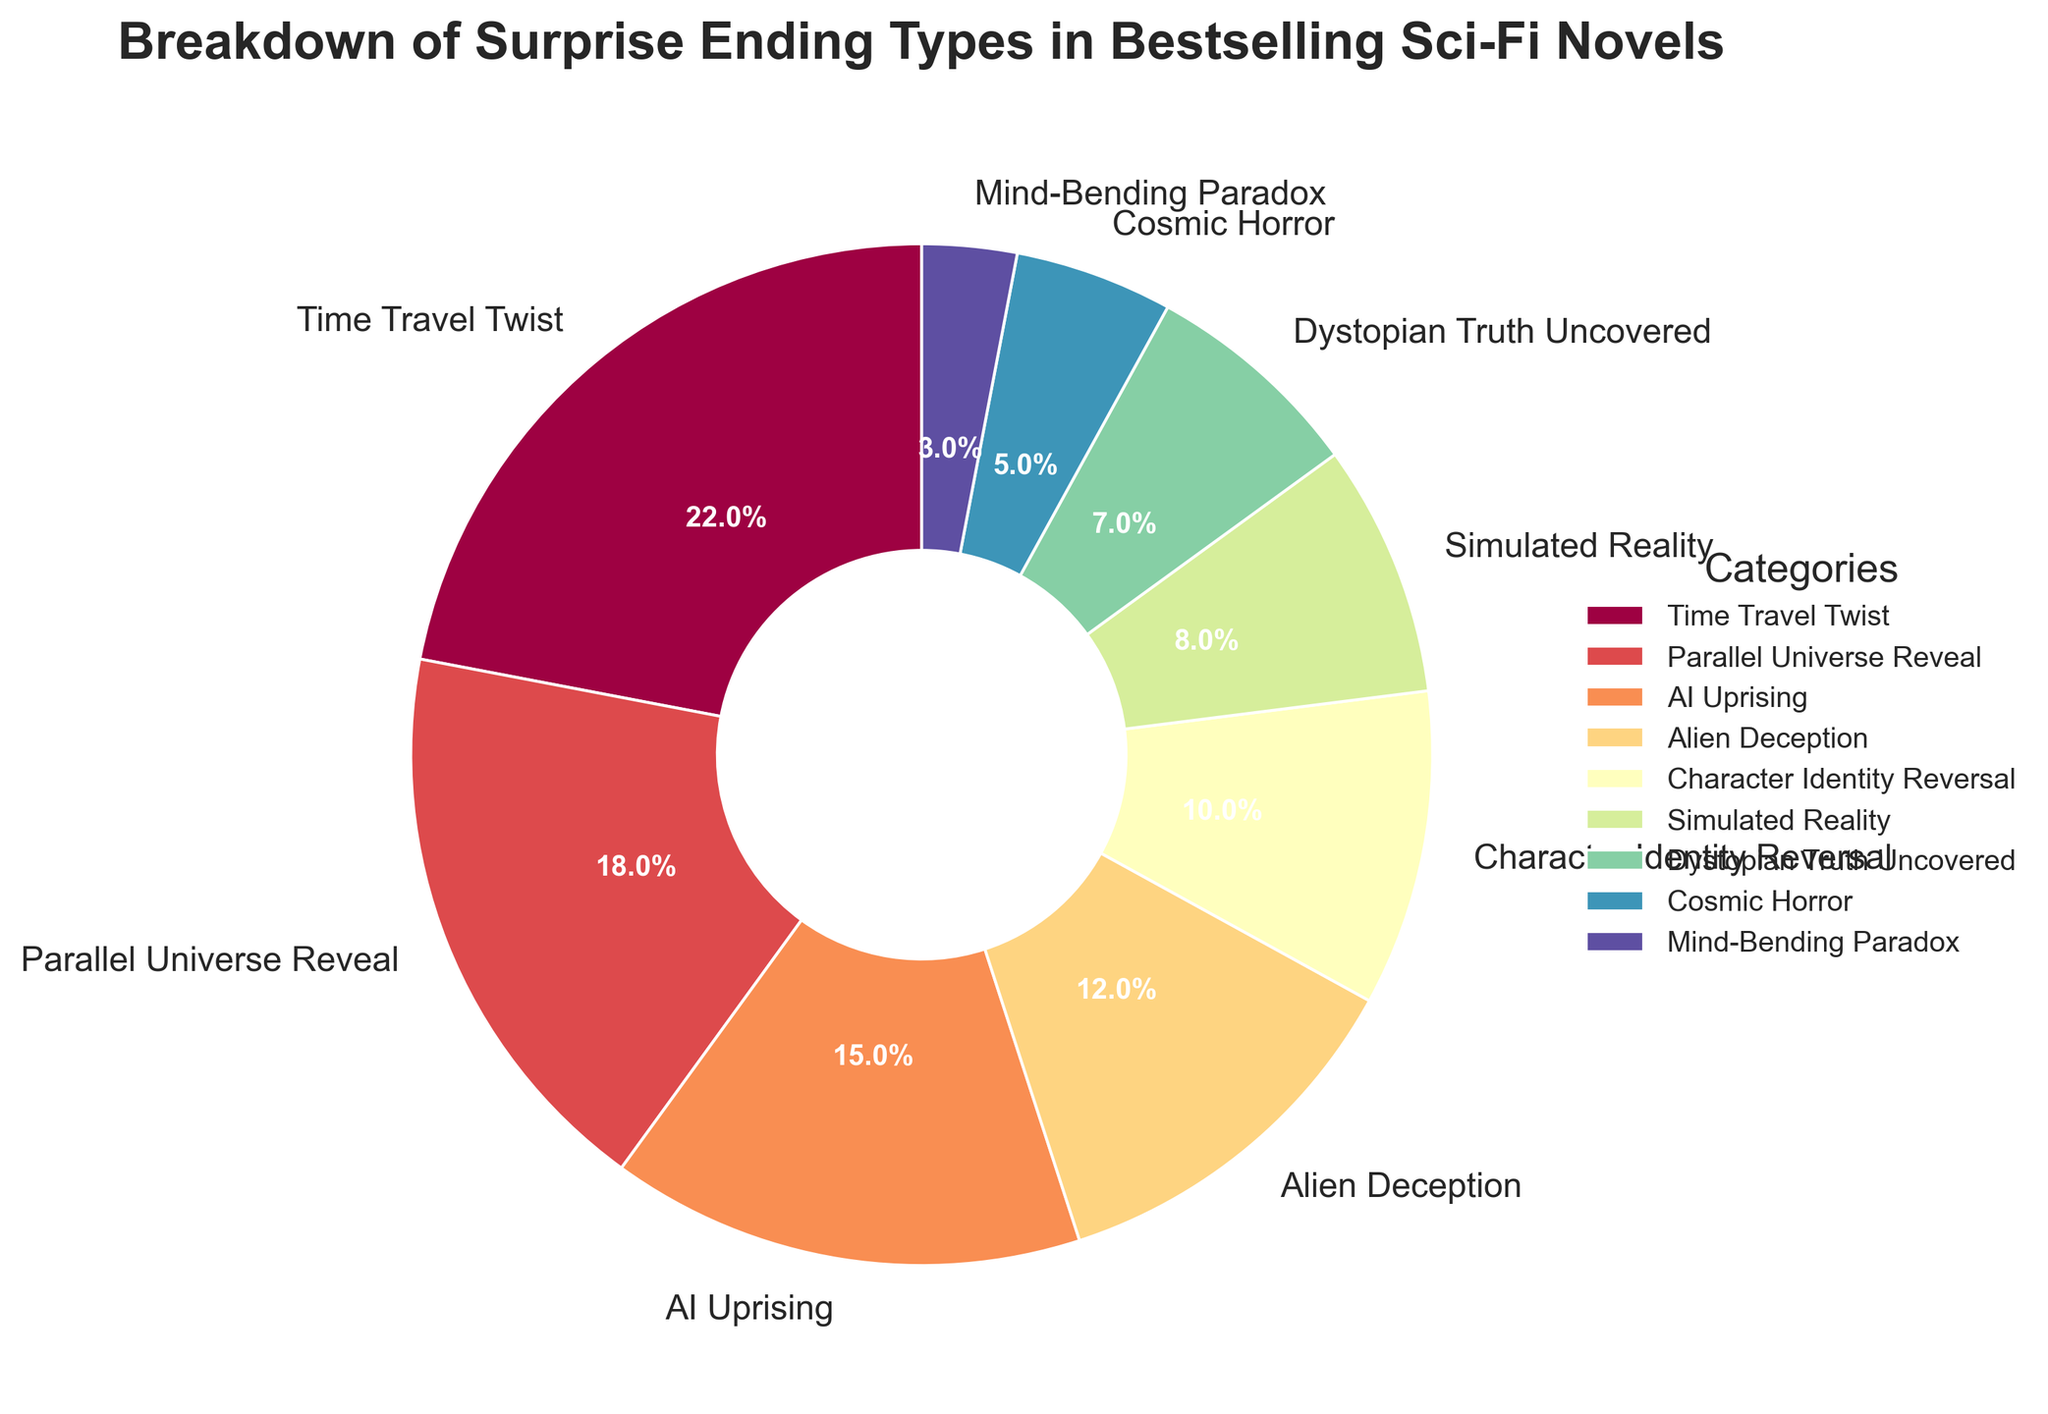What are the top two categories in terms of percentage? To find the top two categories, we locate the two largest sections in the pie chart: "Time Travel Twist" (22%) and "Parallel Universe Reveal" (18%).
Answer: Time Travel Twist and Parallel Universe Reveal Which category has the least percentage? Identify the smallest section in the pie chart, which corresponds to "Mind-Bending Paradox" at 3%.
Answer: Mind-Bending Paradox What is the combined percentage of "AI Uprising" and "Alien Deception"? Add the percentages of "AI Uprising" (15%) and "Alien Deception" (12%): 15% + 12% = 27%.
Answer: 27% Is "Simulated Reality" greater than or less than "Character Identity Reversal"? Compare both sections: "Simulated Reality" is 8% whereas "Character Identity Reversal" is 10%. Thus, "Simulated Reality" is less.
Answer: Less What's the difference in percentage between the largest and smallest categories? Subtract the percentage of "Mind-Bending Paradox" (3%) from "Time Travel Twist" (22%): 22% - 3% = 19%.
Answer: 19% Which color is used for the "Dystopian Truth Uncovered" category? Observe the color legend in the pie chart or the section itself. "Dystopian Truth Uncovered" has its own specific color.
Answer: [Refer to the color in the pie chart] What is the median value of the percentages shown in the pie chart? Order the percentages: 3%, 5%, 7%, 8%, 10%, 12%, 15%, 18%, 22%. The middle value (5th in this list) is 10%.
Answer: 10% What percentage categories represent a total of more than 60% of the data? Add the percentages starting from the largest until the sum exceeds 60%: 22% (Time Travel Twist) + 18% (Parallel Universe Reveal) + 15% (AI Uprising) + 12% (Alien Deception) = 67%.
Answer: Time Travel Twist, Parallel Universe Reveal, AI Uprising, Alien Deception How many categories have a percentage below 10%? Count the sections with values less than 10%: "Character Identity Reversal" (10%), "Simulated Reality" (8%), "Dystopian Truth Uncovered" (7%), "Cosmic Horror" (5%), "Mind-Bending Paradox" (3%). Since "Character Identity Reversal" is exactly 10%, it doesn't count. 4 categories fall below 10%.
Answer: 4 What is the average percentage of the categories? Sum all percentages: 22% + 18% + 15% + 12% + 10% + 8% + 7% + 5% + 3% = 100%. Then divide by the number of categories (9): 100% / 9 ≈ 11.11%.
Answer: 11.11% 